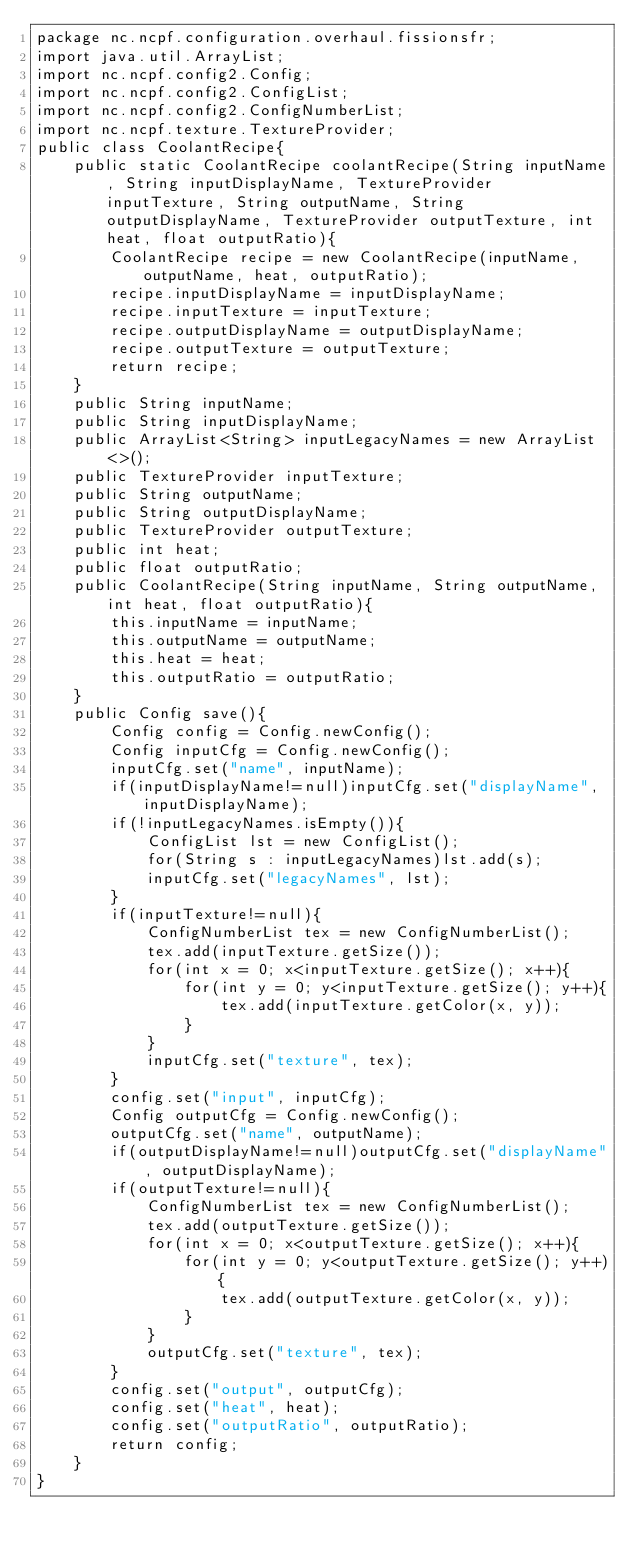<code> <loc_0><loc_0><loc_500><loc_500><_Java_>package nc.ncpf.configuration.overhaul.fissionsfr;
import java.util.ArrayList;
import nc.ncpf.config2.Config;
import nc.ncpf.config2.ConfigList;
import nc.ncpf.config2.ConfigNumberList;
import nc.ncpf.texture.TextureProvider;
public class CoolantRecipe{
    public static CoolantRecipe coolantRecipe(String inputName, String inputDisplayName, TextureProvider inputTexture, String outputName, String outputDisplayName, TextureProvider outputTexture, int heat, float outputRatio){
        CoolantRecipe recipe = new CoolantRecipe(inputName, outputName, heat, outputRatio);
        recipe.inputDisplayName = inputDisplayName;
        recipe.inputTexture = inputTexture;
        recipe.outputDisplayName = outputDisplayName;
        recipe.outputTexture = outputTexture;
        return recipe;
    }
    public String inputName;
    public String inputDisplayName;
    public ArrayList<String> inputLegacyNames = new ArrayList<>();
    public TextureProvider inputTexture;
    public String outputName;
    public String outputDisplayName;
    public TextureProvider outputTexture;
    public int heat;
    public float outputRatio;
    public CoolantRecipe(String inputName, String outputName, int heat, float outputRatio){
        this.inputName = inputName;
        this.outputName = outputName;
        this.heat = heat;
        this.outputRatio = outputRatio;
    }
    public Config save(){
        Config config = Config.newConfig();
        Config inputCfg = Config.newConfig();
        inputCfg.set("name", inputName);
        if(inputDisplayName!=null)inputCfg.set("displayName", inputDisplayName);
        if(!inputLegacyNames.isEmpty()){
            ConfigList lst = new ConfigList();
            for(String s : inputLegacyNames)lst.add(s);
            inputCfg.set("legacyNames", lst);
        }
        if(inputTexture!=null){
            ConfigNumberList tex = new ConfigNumberList();
            tex.add(inputTexture.getSize());
            for(int x = 0; x<inputTexture.getSize(); x++){
                for(int y = 0; y<inputTexture.getSize(); y++){
                    tex.add(inputTexture.getColor(x, y));
                }
            }
            inputCfg.set("texture", tex);
        }
        config.set("input", inputCfg);
        Config outputCfg = Config.newConfig();
        outputCfg.set("name", outputName);
        if(outputDisplayName!=null)outputCfg.set("displayName", outputDisplayName);
        if(outputTexture!=null){
            ConfigNumberList tex = new ConfigNumberList();
            tex.add(outputTexture.getSize());
            for(int x = 0; x<outputTexture.getSize(); x++){
                for(int y = 0; y<outputTexture.getSize(); y++){
                    tex.add(outputTexture.getColor(x, y));
                }
            }
            outputCfg.set("texture", tex);
        }
        config.set("output", outputCfg);
        config.set("heat", heat);
        config.set("outputRatio", outputRatio);
        return config;
    }
}</code> 